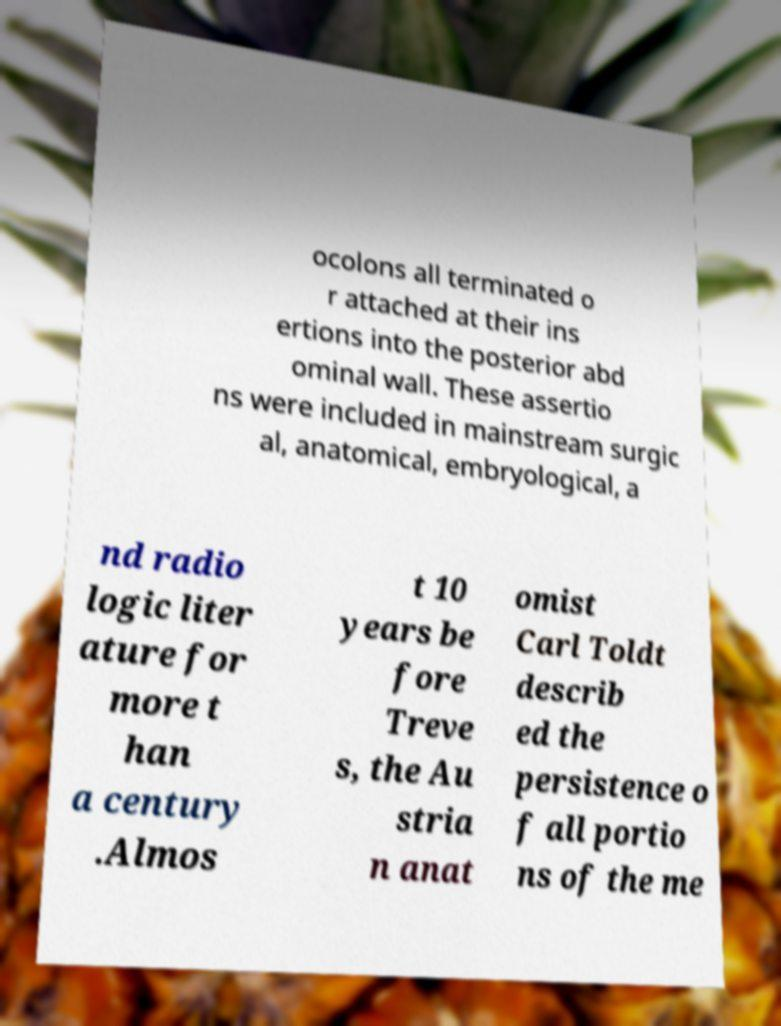Please read and relay the text visible in this image. What does it say? ocolons all terminated o r attached at their ins ertions into the posterior abd ominal wall. These assertio ns were included in mainstream surgic al, anatomical, embryological, a nd radio logic liter ature for more t han a century .Almos t 10 years be fore Treve s, the Au stria n anat omist Carl Toldt describ ed the persistence o f all portio ns of the me 